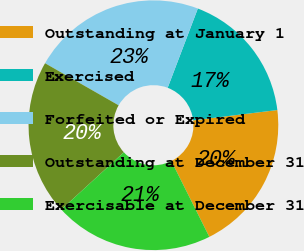<chart> <loc_0><loc_0><loc_500><loc_500><pie_chart><fcel>Outstanding at January 1<fcel>Exercised<fcel>Forfeited or Expired<fcel>Outstanding at December 31<fcel>Exercisable at December 31<nl><fcel>19.55%<fcel>17.27%<fcel>22.52%<fcel>20.07%<fcel>20.59%<nl></chart> 